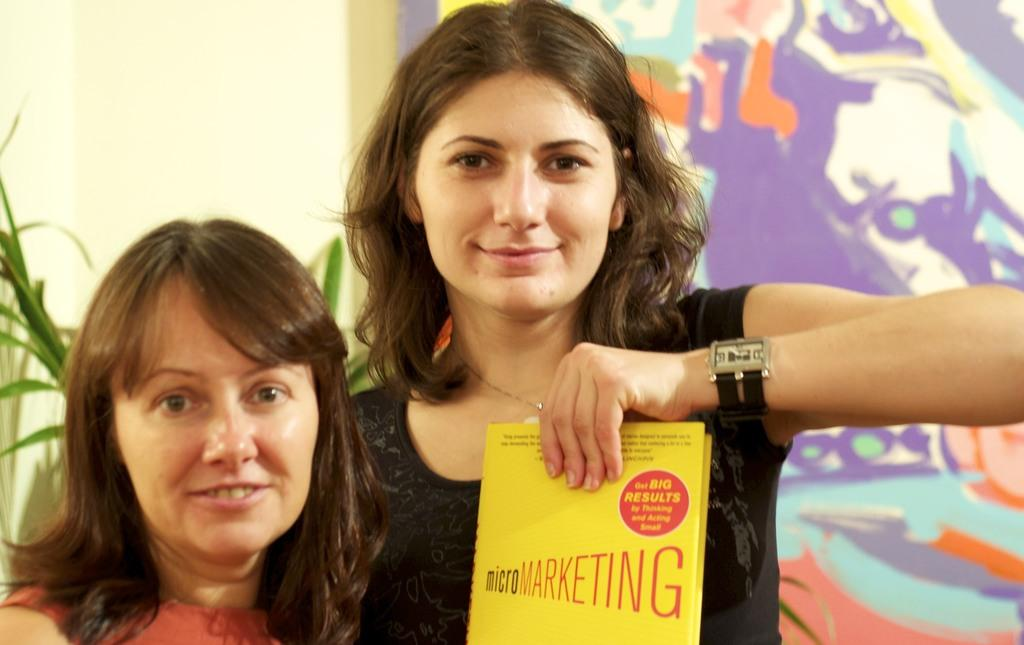<image>
Describe the image concisely. A woman holding a yellow Micro Marketing book. 